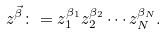<formula> <loc_0><loc_0><loc_500><loc_500>z ^ { \vec { \beta } } \colon = z _ { 1 } ^ { \beta _ { 1 } } z _ { 2 } ^ { \beta _ { 2 } } \cdots z _ { N } ^ { \beta _ { N } } .</formula> 